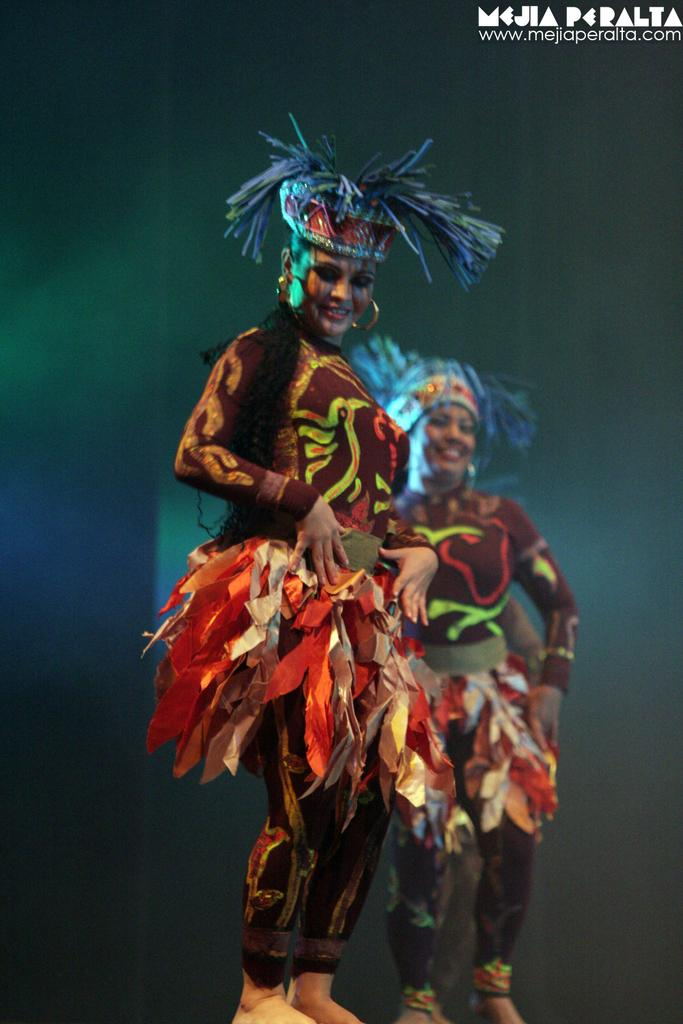How many people are in the image? There are two women in the image. What are the women wearing? The women are wearing costumes. What are the women doing in the image? The women are dancing. Can you describe the appearance of one of the women? One of the women has blue hair, and her dress is in brown and red colors. What type of boat can be seen in the background of the image? There is no boat present in the image; it features two women dancing while wearing costumes. 